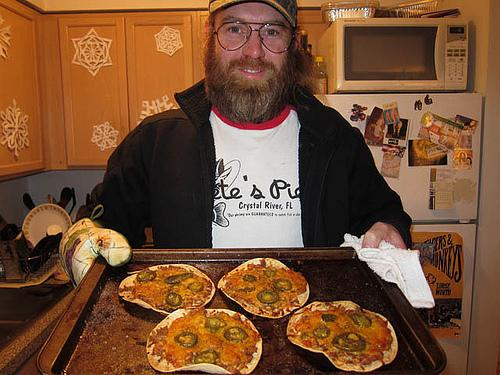How can you tell that this guy likes his food a little spicy?

Choices:
A) salsa
B) jalapenos
C) tabasco
D) hot sauce jalapenos 